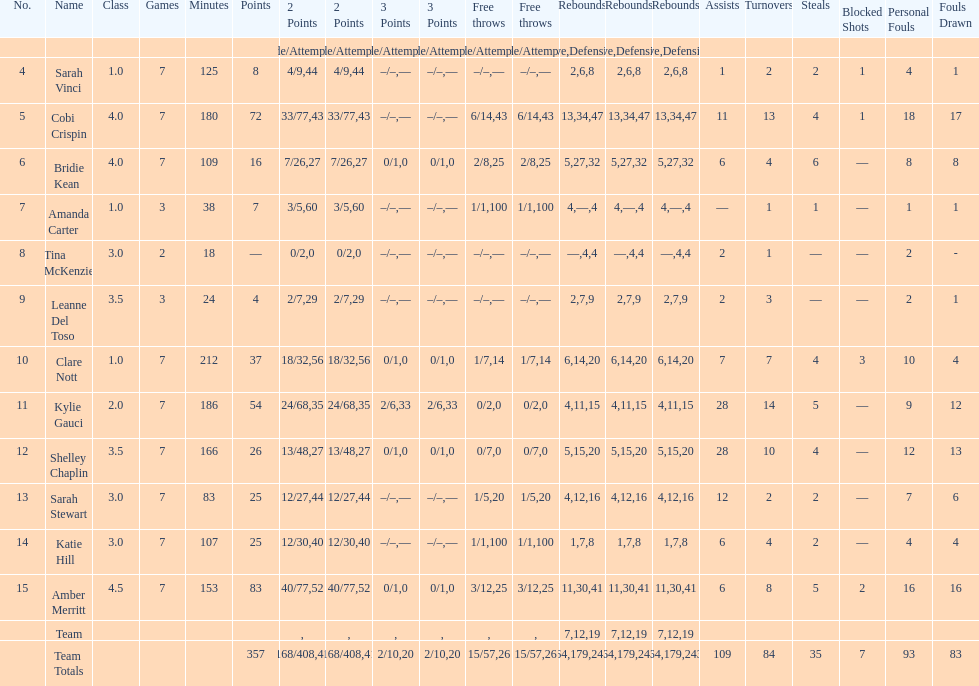Total of three-point shots attempted 10. 